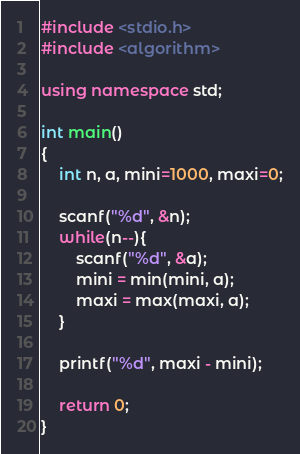<code> <loc_0><loc_0><loc_500><loc_500><_C++_>#include <stdio.h>
#include <algorithm>

using namespace std;

int main()
{
	int n, a, mini=1000, maxi=0;
	
	scanf("%d", &n);
	while(n--){
		scanf("%d", &a);
		mini = min(mini, a);
		maxi = max(maxi, a);
	}
	
	printf("%d", maxi - mini);
	
	return 0;
}</code> 